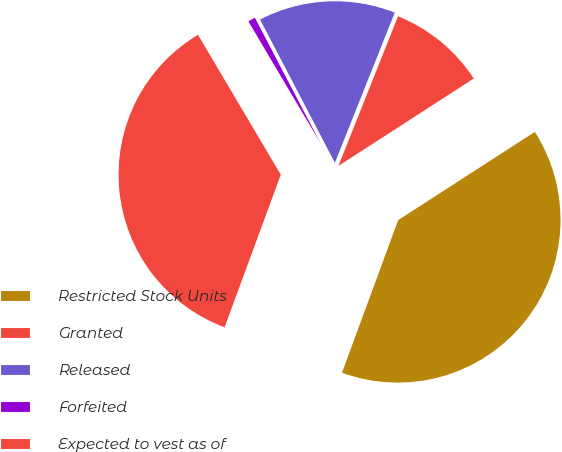<chart> <loc_0><loc_0><loc_500><loc_500><pie_chart><fcel>Restricted Stock Units<fcel>Granted<fcel>Released<fcel>Forfeited<fcel>Expected to vest as of<nl><fcel>39.74%<fcel>9.84%<fcel>13.7%<fcel>0.84%<fcel>35.88%<nl></chart> 